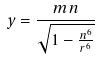<formula> <loc_0><loc_0><loc_500><loc_500>y = \frac { m n } { \sqrt { 1 - \frac { n ^ { 6 } } { r ^ { 6 } } } }</formula> 